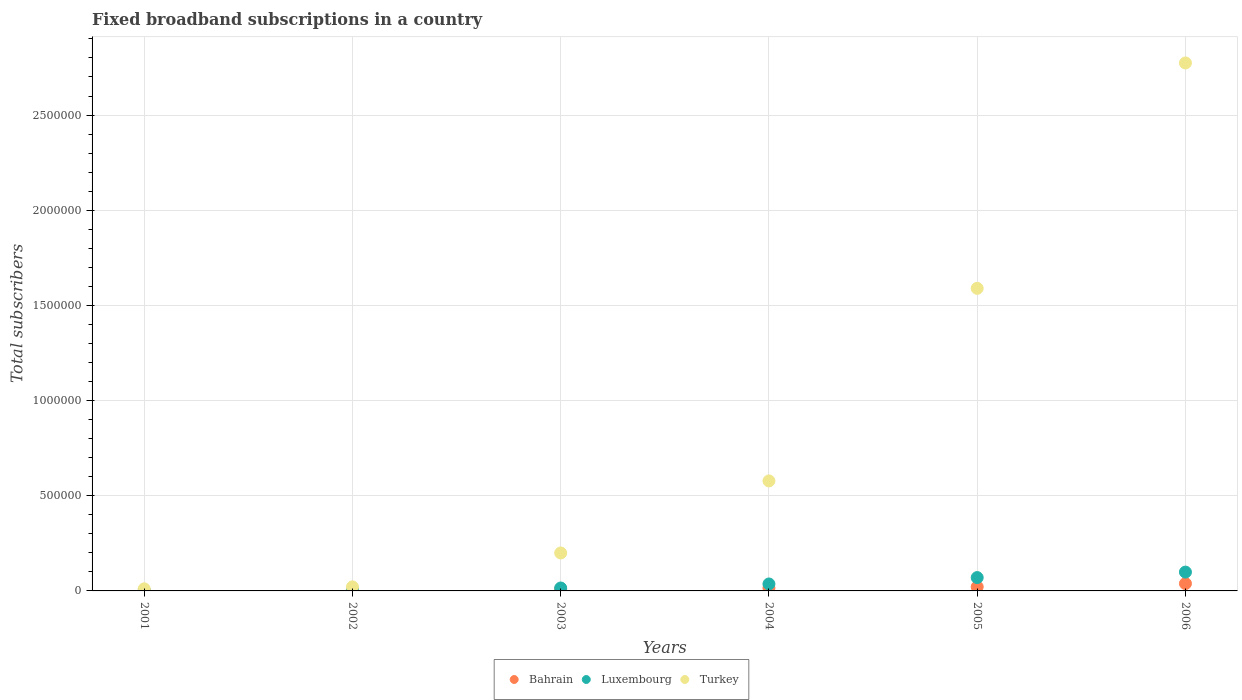How many different coloured dotlines are there?
Your response must be concise. 3. What is the number of broadband subscriptions in Bahrain in 2002?
Keep it short and to the point. 4980. Across all years, what is the maximum number of broadband subscriptions in Turkey?
Your answer should be very brief. 2.77e+06. Across all years, what is the minimum number of broadband subscriptions in Turkey?
Make the answer very short. 1.09e+04. In which year was the number of broadband subscriptions in Luxembourg maximum?
Keep it short and to the point. 2006. In which year was the number of broadband subscriptions in Luxembourg minimum?
Give a very brief answer. 2001. What is the total number of broadband subscriptions in Turkey in the graph?
Keep it short and to the point. 5.17e+06. What is the difference between the number of broadband subscriptions in Luxembourg in 2004 and that in 2005?
Provide a succinct answer. -3.36e+04. What is the difference between the number of broadband subscriptions in Bahrain in 2004 and the number of broadband subscriptions in Luxembourg in 2002?
Provide a succinct answer. 9129. What is the average number of broadband subscriptions in Luxembourg per year?
Your response must be concise. 3.80e+04. In the year 2006, what is the difference between the number of broadband subscriptions in Turkey and number of broadband subscriptions in Bahrain?
Ensure brevity in your answer.  2.74e+06. In how many years, is the number of broadband subscriptions in Luxembourg greater than 2400000?
Provide a short and direct response. 0. What is the ratio of the number of broadband subscriptions in Bahrain in 2003 to that in 2006?
Ensure brevity in your answer.  0.25. Is the number of broadband subscriptions in Luxembourg in 2001 less than that in 2005?
Keep it short and to the point. Yes. What is the difference between the highest and the second highest number of broadband subscriptions in Luxembourg?
Your answer should be compact. 2.88e+04. What is the difference between the highest and the lowest number of broadband subscriptions in Turkey?
Your response must be concise. 2.76e+06. Is it the case that in every year, the sum of the number of broadband subscriptions in Turkey and number of broadband subscriptions in Luxembourg  is greater than the number of broadband subscriptions in Bahrain?
Your answer should be very brief. Yes. Does the number of broadband subscriptions in Bahrain monotonically increase over the years?
Your response must be concise. Yes. Is the number of broadband subscriptions in Bahrain strictly greater than the number of broadband subscriptions in Turkey over the years?
Your response must be concise. No. Is the number of broadband subscriptions in Luxembourg strictly less than the number of broadband subscriptions in Turkey over the years?
Your response must be concise. Yes. How many dotlines are there?
Offer a terse response. 3. How many years are there in the graph?
Your answer should be very brief. 6. Does the graph contain any zero values?
Offer a very short reply. No. Does the graph contain grids?
Provide a short and direct response. Yes. Where does the legend appear in the graph?
Your answer should be very brief. Bottom center. How many legend labels are there?
Your answer should be very brief. 3. How are the legend labels stacked?
Ensure brevity in your answer.  Horizontal. What is the title of the graph?
Offer a very short reply. Fixed broadband subscriptions in a country. What is the label or title of the Y-axis?
Your answer should be very brief. Total subscribers. What is the Total subscribers in Bahrain in 2001?
Provide a succinct answer. 1176. What is the Total subscribers of Luxembourg in 2001?
Offer a terse response. 1215. What is the Total subscribers in Turkey in 2001?
Your answer should be very brief. 1.09e+04. What is the Total subscribers in Bahrain in 2002?
Provide a short and direct response. 4980. What is the Total subscribers in Luxembourg in 2002?
Ensure brevity in your answer.  5827. What is the Total subscribers in Turkey in 2002?
Make the answer very short. 2.12e+04. What is the Total subscribers in Bahrain in 2003?
Provide a short and direct response. 9737. What is the Total subscribers in Luxembourg in 2003?
Give a very brief answer. 1.54e+04. What is the Total subscribers in Turkey in 2003?
Your response must be concise. 1.99e+05. What is the Total subscribers of Bahrain in 2004?
Make the answer very short. 1.50e+04. What is the Total subscribers of Luxembourg in 2004?
Your answer should be compact. 3.65e+04. What is the Total subscribers in Turkey in 2004?
Provide a succinct answer. 5.78e+05. What is the Total subscribers in Bahrain in 2005?
Your response must be concise. 2.14e+04. What is the Total subscribers of Luxembourg in 2005?
Give a very brief answer. 7.01e+04. What is the Total subscribers in Turkey in 2005?
Provide a succinct answer. 1.59e+06. What is the Total subscribers in Bahrain in 2006?
Keep it short and to the point. 3.86e+04. What is the Total subscribers in Luxembourg in 2006?
Offer a terse response. 9.89e+04. What is the Total subscribers of Turkey in 2006?
Ensure brevity in your answer.  2.77e+06. Across all years, what is the maximum Total subscribers in Bahrain?
Offer a very short reply. 3.86e+04. Across all years, what is the maximum Total subscribers in Luxembourg?
Provide a succinct answer. 9.89e+04. Across all years, what is the maximum Total subscribers in Turkey?
Your answer should be very brief. 2.77e+06. Across all years, what is the minimum Total subscribers in Bahrain?
Keep it short and to the point. 1176. Across all years, what is the minimum Total subscribers in Luxembourg?
Provide a succinct answer. 1215. Across all years, what is the minimum Total subscribers in Turkey?
Provide a succinct answer. 1.09e+04. What is the total Total subscribers in Bahrain in the graph?
Provide a short and direct response. 9.09e+04. What is the total Total subscribers in Luxembourg in the graph?
Offer a terse response. 2.28e+05. What is the total Total subscribers of Turkey in the graph?
Give a very brief answer. 5.17e+06. What is the difference between the Total subscribers of Bahrain in 2001 and that in 2002?
Your answer should be very brief. -3804. What is the difference between the Total subscribers of Luxembourg in 2001 and that in 2002?
Ensure brevity in your answer.  -4612. What is the difference between the Total subscribers of Turkey in 2001 and that in 2002?
Offer a terse response. -1.03e+04. What is the difference between the Total subscribers in Bahrain in 2001 and that in 2003?
Your answer should be compact. -8561. What is the difference between the Total subscribers in Luxembourg in 2001 and that in 2003?
Offer a terse response. -1.41e+04. What is the difference between the Total subscribers of Turkey in 2001 and that in 2003?
Provide a succinct answer. -1.88e+05. What is the difference between the Total subscribers of Bahrain in 2001 and that in 2004?
Your response must be concise. -1.38e+04. What is the difference between the Total subscribers of Luxembourg in 2001 and that in 2004?
Offer a terse response. -3.53e+04. What is the difference between the Total subscribers in Turkey in 2001 and that in 2004?
Offer a terse response. -5.67e+05. What is the difference between the Total subscribers in Bahrain in 2001 and that in 2005?
Keep it short and to the point. -2.03e+04. What is the difference between the Total subscribers of Luxembourg in 2001 and that in 2005?
Keep it short and to the point. -6.89e+04. What is the difference between the Total subscribers in Turkey in 2001 and that in 2005?
Offer a very short reply. -1.58e+06. What is the difference between the Total subscribers in Bahrain in 2001 and that in 2006?
Give a very brief answer. -3.75e+04. What is the difference between the Total subscribers of Luxembourg in 2001 and that in 2006?
Your answer should be compact. -9.77e+04. What is the difference between the Total subscribers of Turkey in 2001 and that in 2006?
Give a very brief answer. -2.76e+06. What is the difference between the Total subscribers of Bahrain in 2002 and that in 2003?
Make the answer very short. -4757. What is the difference between the Total subscribers of Luxembourg in 2002 and that in 2003?
Keep it short and to the point. -9524. What is the difference between the Total subscribers of Turkey in 2002 and that in 2003?
Provide a succinct answer. -1.78e+05. What is the difference between the Total subscribers in Bahrain in 2002 and that in 2004?
Make the answer very short. -9976. What is the difference between the Total subscribers in Luxembourg in 2002 and that in 2004?
Offer a very short reply. -3.07e+04. What is the difference between the Total subscribers in Turkey in 2002 and that in 2004?
Your answer should be compact. -5.57e+05. What is the difference between the Total subscribers in Bahrain in 2002 and that in 2005?
Offer a very short reply. -1.65e+04. What is the difference between the Total subscribers in Luxembourg in 2002 and that in 2005?
Your answer should be very brief. -6.43e+04. What is the difference between the Total subscribers in Turkey in 2002 and that in 2005?
Keep it short and to the point. -1.57e+06. What is the difference between the Total subscribers of Bahrain in 2002 and that in 2006?
Offer a terse response. -3.36e+04. What is the difference between the Total subscribers in Luxembourg in 2002 and that in 2006?
Keep it short and to the point. -9.31e+04. What is the difference between the Total subscribers of Turkey in 2002 and that in 2006?
Make the answer very short. -2.75e+06. What is the difference between the Total subscribers in Bahrain in 2003 and that in 2004?
Your answer should be very brief. -5219. What is the difference between the Total subscribers of Luxembourg in 2003 and that in 2004?
Offer a terse response. -2.11e+04. What is the difference between the Total subscribers of Turkey in 2003 and that in 2004?
Provide a succinct answer. -3.79e+05. What is the difference between the Total subscribers of Bahrain in 2003 and that in 2005?
Provide a succinct answer. -1.17e+04. What is the difference between the Total subscribers of Luxembourg in 2003 and that in 2005?
Provide a short and direct response. -5.47e+04. What is the difference between the Total subscribers of Turkey in 2003 and that in 2005?
Your response must be concise. -1.39e+06. What is the difference between the Total subscribers in Bahrain in 2003 and that in 2006?
Provide a short and direct response. -2.89e+04. What is the difference between the Total subscribers in Luxembourg in 2003 and that in 2006?
Ensure brevity in your answer.  -8.36e+04. What is the difference between the Total subscribers in Turkey in 2003 and that in 2006?
Ensure brevity in your answer.  -2.57e+06. What is the difference between the Total subscribers in Bahrain in 2004 and that in 2005?
Give a very brief answer. -6476. What is the difference between the Total subscribers of Luxembourg in 2004 and that in 2005?
Offer a very short reply. -3.36e+04. What is the difference between the Total subscribers in Turkey in 2004 and that in 2005?
Make the answer very short. -1.01e+06. What is the difference between the Total subscribers in Bahrain in 2004 and that in 2006?
Keep it short and to the point. -2.37e+04. What is the difference between the Total subscribers in Luxembourg in 2004 and that in 2006?
Give a very brief answer. -6.24e+04. What is the difference between the Total subscribers in Turkey in 2004 and that in 2006?
Your answer should be very brief. -2.20e+06. What is the difference between the Total subscribers in Bahrain in 2005 and that in 2006?
Provide a succinct answer. -1.72e+04. What is the difference between the Total subscribers in Luxembourg in 2005 and that in 2006?
Your answer should be very brief. -2.88e+04. What is the difference between the Total subscribers in Turkey in 2005 and that in 2006?
Your answer should be very brief. -1.18e+06. What is the difference between the Total subscribers in Bahrain in 2001 and the Total subscribers in Luxembourg in 2002?
Ensure brevity in your answer.  -4651. What is the difference between the Total subscribers in Bahrain in 2001 and the Total subscribers in Turkey in 2002?
Provide a short and direct response. -2.00e+04. What is the difference between the Total subscribers in Luxembourg in 2001 and the Total subscribers in Turkey in 2002?
Offer a very short reply. -2.00e+04. What is the difference between the Total subscribers in Bahrain in 2001 and the Total subscribers in Luxembourg in 2003?
Give a very brief answer. -1.42e+04. What is the difference between the Total subscribers of Bahrain in 2001 and the Total subscribers of Turkey in 2003?
Offer a terse response. -1.98e+05. What is the difference between the Total subscribers of Luxembourg in 2001 and the Total subscribers of Turkey in 2003?
Your answer should be very brief. -1.98e+05. What is the difference between the Total subscribers in Bahrain in 2001 and the Total subscribers in Luxembourg in 2004?
Provide a succinct answer. -3.53e+04. What is the difference between the Total subscribers of Bahrain in 2001 and the Total subscribers of Turkey in 2004?
Keep it short and to the point. -5.77e+05. What is the difference between the Total subscribers in Luxembourg in 2001 and the Total subscribers in Turkey in 2004?
Give a very brief answer. -5.77e+05. What is the difference between the Total subscribers of Bahrain in 2001 and the Total subscribers of Luxembourg in 2005?
Keep it short and to the point. -6.89e+04. What is the difference between the Total subscribers of Bahrain in 2001 and the Total subscribers of Turkey in 2005?
Your answer should be very brief. -1.59e+06. What is the difference between the Total subscribers of Luxembourg in 2001 and the Total subscribers of Turkey in 2005?
Offer a very short reply. -1.59e+06. What is the difference between the Total subscribers in Bahrain in 2001 and the Total subscribers in Luxembourg in 2006?
Your answer should be compact. -9.78e+04. What is the difference between the Total subscribers of Bahrain in 2001 and the Total subscribers of Turkey in 2006?
Your answer should be very brief. -2.77e+06. What is the difference between the Total subscribers in Luxembourg in 2001 and the Total subscribers in Turkey in 2006?
Keep it short and to the point. -2.77e+06. What is the difference between the Total subscribers of Bahrain in 2002 and the Total subscribers of Luxembourg in 2003?
Keep it short and to the point. -1.04e+04. What is the difference between the Total subscribers in Bahrain in 2002 and the Total subscribers in Turkey in 2003?
Your response must be concise. -1.94e+05. What is the difference between the Total subscribers of Luxembourg in 2002 and the Total subscribers of Turkey in 2003?
Make the answer very short. -1.93e+05. What is the difference between the Total subscribers of Bahrain in 2002 and the Total subscribers of Luxembourg in 2004?
Provide a short and direct response. -3.15e+04. What is the difference between the Total subscribers in Bahrain in 2002 and the Total subscribers in Turkey in 2004?
Give a very brief answer. -5.73e+05. What is the difference between the Total subscribers of Luxembourg in 2002 and the Total subscribers of Turkey in 2004?
Your answer should be very brief. -5.72e+05. What is the difference between the Total subscribers in Bahrain in 2002 and the Total subscribers in Luxembourg in 2005?
Ensure brevity in your answer.  -6.51e+04. What is the difference between the Total subscribers of Bahrain in 2002 and the Total subscribers of Turkey in 2005?
Ensure brevity in your answer.  -1.58e+06. What is the difference between the Total subscribers in Luxembourg in 2002 and the Total subscribers in Turkey in 2005?
Your answer should be very brief. -1.58e+06. What is the difference between the Total subscribers in Bahrain in 2002 and the Total subscribers in Luxembourg in 2006?
Your answer should be compact. -9.40e+04. What is the difference between the Total subscribers of Bahrain in 2002 and the Total subscribers of Turkey in 2006?
Offer a very short reply. -2.77e+06. What is the difference between the Total subscribers of Luxembourg in 2002 and the Total subscribers of Turkey in 2006?
Ensure brevity in your answer.  -2.77e+06. What is the difference between the Total subscribers in Bahrain in 2003 and the Total subscribers in Luxembourg in 2004?
Provide a short and direct response. -2.68e+04. What is the difference between the Total subscribers in Bahrain in 2003 and the Total subscribers in Turkey in 2004?
Offer a very short reply. -5.68e+05. What is the difference between the Total subscribers in Luxembourg in 2003 and the Total subscribers in Turkey in 2004?
Ensure brevity in your answer.  -5.63e+05. What is the difference between the Total subscribers in Bahrain in 2003 and the Total subscribers in Luxembourg in 2005?
Keep it short and to the point. -6.04e+04. What is the difference between the Total subscribers in Bahrain in 2003 and the Total subscribers in Turkey in 2005?
Give a very brief answer. -1.58e+06. What is the difference between the Total subscribers in Luxembourg in 2003 and the Total subscribers in Turkey in 2005?
Give a very brief answer. -1.57e+06. What is the difference between the Total subscribers of Bahrain in 2003 and the Total subscribers of Luxembourg in 2006?
Provide a succinct answer. -8.92e+04. What is the difference between the Total subscribers in Bahrain in 2003 and the Total subscribers in Turkey in 2006?
Your answer should be compact. -2.76e+06. What is the difference between the Total subscribers of Luxembourg in 2003 and the Total subscribers of Turkey in 2006?
Provide a short and direct response. -2.76e+06. What is the difference between the Total subscribers of Bahrain in 2004 and the Total subscribers of Luxembourg in 2005?
Offer a very short reply. -5.51e+04. What is the difference between the Total subscribers of Bahrain in 2004 and the Total subscribers of Turkey in 2005?
Keep it short and to the point. -1.57e+06. What is the difference between the Total subscribers in Luxembourg in 2004 and the Total subscribers in Turkey in 2005?
Provide a succinct answer. -1.55e+06. What is the difference between the Total subscribers in Bahrain in 2004 and the Total subscribers in Luxembourg in 2006?
Provide a short and direct response. -8.40e+04. What is the difference between the Total subscribers of Bahrain in 2004 and the Total subscribers of Turkey in 2006?
Your answer should be very brief. -2.76e+06. What is the difference between the Total subscribers of Luxembourg in 2004 and the Total subscribers of Turkey in 2006?
Your response must be concise. -2.74e+06. What is the difference between the Total subscribers of Bahrain in 2005 and the Total subscribers of Luxembourg in 2006?
Give a very brief answer. -7.75e+04. What is the difference between the Total subscribers in Bahrain in 2005 and the Total subscribers in Turkey in 2006?
Offer a very short reply. -2.75e+06. What is the difference between the Total subscribers of Luxembourg in 2005 and the Total subscribers of Turkey in 2006?
Your answer should be compact. -2.70e+06. What is the average Total subscribers in Bahrain per year?
Your answer should be compact. 1.52e+04. What is the average Total subscribers in Luxembourg per year?
Make the answer very short. 3.80e+04. What is the average Total subscribers in Turkey per year?
Provide a short and direct response. 8.62e+05. In the year 2001, what is the difference between the Total subscribers in Bahrain and Total subscribers in Luxembourg?
Offer a very short reply. -39. In the year 2001, what is the difference between the Total subscribers in Bahrain and Total subscribers in Turkey?
Offer a very short reply. -9739. In the year 2001, what is the difference between the Total subscribers in Luxembourg and Total subscribers in Turkey?
Your answer should be compact. -9700. In the year 2002, what is the difference between the Total subscribers in Bahrain and Total subscribers in Luxembourg?
Provide a short and direct response. -847. In the year 2002, what is the difference between the Total subscribers in Bahrain and Total subscribers in Turkey?
Provide a succinct answer. -1.62e+04. In the year 2002, what is the difference between the Total subscribers in Luxembourg and Total subscribers in Turkey?
Offer a very short reply. -1.54e+04. In the year 2003, what is the difference between the Total subscribers in Bahrain and Total subscribers in Luxembourg?
Your response must be concise. -5614. In the year 2003, what is the difference between the Total subscribers in Bahrain and Total subscribers in Turkey?
Your answer should be compact. -1.90e+05. In the year 2003, what is the difference between the Total subscribers of Luxembourg and Total subscribers of Turkey?
Offer a terse response. -1.84e+05. In the year 2004, what is the difference between the Total subscribers of Bahrain and Total subscribers of Luxembourg?
Your answer should be compact. -2.15e+04. In the year 2004, what is the difference between the Total subscribers in Bahrain and Total subscribers in Turkey?
Offer a very short reply. -5.63e+05. In the year 2004, what is the difference between the Total subscribers of Luxembourg and Total subscribers of Turkey?
Ensure brevity in your answer.  -5.41e+05. In the year 2005, what is the difference between the Total subscribers of Bahrain and Total subscribers of Luxembourg?
Provide a short and direct response. -4.87e+04. In the year 2005, what is the difference between the Total subscribers in Bahrain and Total subscribers in Turkey?
Ensure brevity in your answer.  -1.57e+06. In the year 2005, what is the difference between the Total subscribers in Luxembourg and Total subscribers in Turkey?
Offer a very short reply. -1.52e+06. In the year 2006, what is the difference between the Total subscribers of Bahrain and Total subscribers of Luxembourg?
Your answer should be very brief. -6.03e+04. In the year 2006, what is the difference between the Total subscribers in Bahrain and Total subscribers in Turkey?
Offer a very short reply. -2.74e+06. In the year 2006, what is the difference between the Total subscribers in Luxembourg and Total subscribers in Turkey?
Your answer should be compact. -2.67e+06. What is the ratio of the Total subscribers of Bahrain in 2001 to that in 2002?
Provide a short and direct response. 0.24. What is the ratio of the Total subscribers of Luxembourg in 2001 to that in 2002?
Make the answer very short. 0.21. What is the ratio of the Total subscribers in Turkey in 2001 to that in 2002?
Your answer should be very brief. 0.51. What is the ratio of the Total subscribers of Bahrain in 2001 to that in 2003?
Provide a succinct answer. 0.12. What is the ratio of the Total subscribers in Luxembourg in 2001 to that in 2003?
Provide a short and direct response. 0.08. What is the ratio of the Total subscribers in Turkey in 2001 to that in 2003?
Keep it short and to the point. 0.05. What is the ratio of the Total subscribers of Bahrain in 2001 to that in 2004?
Make the answer very short. 0.08. What is the ratio of the Total subscribers in Turkey in 2001 to that in 2004?
Give a very brief answer. 0.02. What is the ratio of the Total subscribers of Bahrain in 2001 to that in 2005?
Ensure brevity in your answer.  0.05. What is the ratio of the Total subscribers of Luxembourg in 2001 to that in 2005?
Keep it short and to the point. 0.02. What is the ratio of the Total subscribers in Turkey in 2001 to that in 2005?
Your answer should be compact. 0.01. What is the ratio of the Total subscribers of Bahrain in 2001 to that in 2006?
Your response must be concise. 0.03. What is the ratio of the Total subscribers in Luxembourg in 2001 to that in 2006?
Provide a succinct answer. 0.01. What is the ratio of the Total subscribers in Turkey in 2001 to that in 2006?
Give a very brief answer. 0. What is the ratio of the Total subscribers of Bahrain in 2002 to that in 2003?
Offer a terse response. 0.51. What is the ratio of the Total subscribers of Luxembourg in 2002 to that in 2003?
Keep it short and to the point. 0.38. What is the ratio of the Total subscribers in Turkey in 2002 to that in 2003?
Make the answer very short. 0.11. What is the ratio of the Total subscribers in Bahrain in 2002 to that in 2004?
Ensure brevity in your answer.  0.33. What is the ratio of the Total subscribers in Luxembourg in 2002 to that in 2004?
Your answer should be compact. 0.16. What is the ratio of the Total subscribers of Turkey in 2002 to that in 2004?
Your answer should be compact. 0.04. What is the ratio of the Total subscribers of Bahrain in 2002 to that in 2005?
Provide a succinct answer. 0.23. What is the ratio of the Total subscribers of Luxembourg in 2002 to that in 2005?
Your response must be concise. 0.08. What is the ratio of the Total subscribers of Turkey in 2002 to that in 2005?
Provide a short and direct response. 0.01. What is the ratio of the Total subscribers of Bahrain in 2002 to that in 2006?
Your response must be concise. 0.13. What is the ratio of the Total subscribers in Luxembourg in 2002 to that in 2006?
Give a very brief answer. 0.06. What is the ratio of the Total subscribers in Turkey in 2002 to that in 2006?
Keep it short and to the point. 0.01. What is the ratio of the Total subscribers of Bahrain in 2003 to that in 2004?
Your response must be concise. 0.65. What is the ratio of the Total subscribers in Luxembourg in 2003 to that in 2004?
Offer a very short reply. 0.42. What is the ratio of the Total subscribers in Turkey in 2003 to that in 2004?
Provide a short and direct response. 0.34. What is the ratio of the Total subscribers of Bahrain in 2003 to that in 2005?
Your answer should be compact. 0.45. What is the ratio of the Total subscribers in Luxembourg in 2003 to that in 2005?
Give a very brief answer. 0.22. What is the ratio of the Total subscribers of Turkey in 2003 to that in 2005?
Your answer should be compact. 0.13. What is the ratio of the Total subscribers of Bahrain in 2003 to that in 2006?
Provide a short and direct response. 0.25. What is the ratio of the Total subscribers in Luxembourg in 2003 to that in 2006?
Offer a terse response. 0.16. What is the ratio of the Total subscribers of Turkey in 2003 to that in 2006?
Provide a short and direct response. 0.07. What is the ratio of the Total subscribers in Bahrain in 2004 to that in 2005?
Offer a terse response. 0.7. What is the ratio of the Total subscribers of Luxembourg in 2004 to that in 2005?
Your response must be concise. 0.52. What is the ratio of the Total subscribers in Turkey in 2004 to that in 2005?
Your answer should be very brief. 0.36. What is the ratio of the Total subscribers in Bahrain in 2004 to that in 2006?
Your response must be concise. 0.39. What is the ratio of the Total subscribers of Luxembourg in 2004 to that in 2006?
Your answer should be very brief. 0.37. What is the ratio of the Total subscribers of Turkey in 2004 to that in 2006?
Your answer should be compact. 0.21. What is the ratio of the Total subscribers in Bahrain in 2005 to that in 2006?
Your answer should be very brief. 0.55. What is the ratio of the Total subscribers of Luxembourg in 2005 to that in 2006?
Keep it short and to the point. 0.71. What is the ratio of the Total subscribers in Turkey in 2005 to that in 2006?
Your answer should be compact. 0.57. What is the difference between the highest and the second highest Total subscribers in Bahrain?
Make the answer very short. 1.72e+04. What is the difference between the highest and the second highest Total subscribers in Luxembourg?
Your answer should be very brief. 2.88e+04. What is the difference between the highest and the second highest Total subscribers of Turkey?
Offer a terse response. 1.18e+06. What is the difference between the highest and the lowest Total subscribers in Bahrain?
Keep it short and to the point. 3.75e+04. What is the difference between the highest and the lowest Total subscribers of Luxembourg?
Provide a short and direct response. 9.77e+04. What is the difference between the highest and the lowest Total subscribers of Turkey?
Make the answer very short. 2.76e+06. 